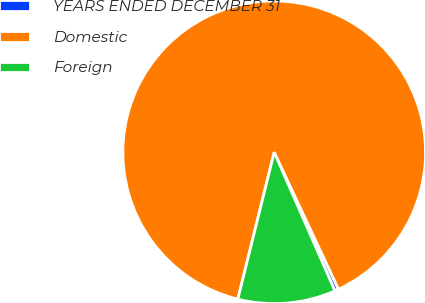Convert chart. <chart><loc_0><loc_0><loc_500><loc_500><pie_chart><fcel>YEARS ENDED DECEMBER 31<fcel>Domestic<fcel>Foreign<nl><fcel>0.41%<fcel>89.16%<fcel>10.44%<nl></chart> 